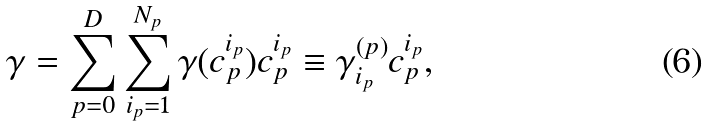Convert formula to latex. <formula><loc_0><loc_0><loc_500><loc_500>\gamma = \sum _ { p = 0 } ^ { D } \sum _ { i _ { p } = 1 } ^ { N _ { p } } \gamma ( c _ { p } ^ { i _ { p } } ) c _ { p } ^ { i _ { p } } \equiv \gamma _ { i _ { p } } ^ { ( p ) } c _ { p } ^ { i _ { p } } ,</formula> 